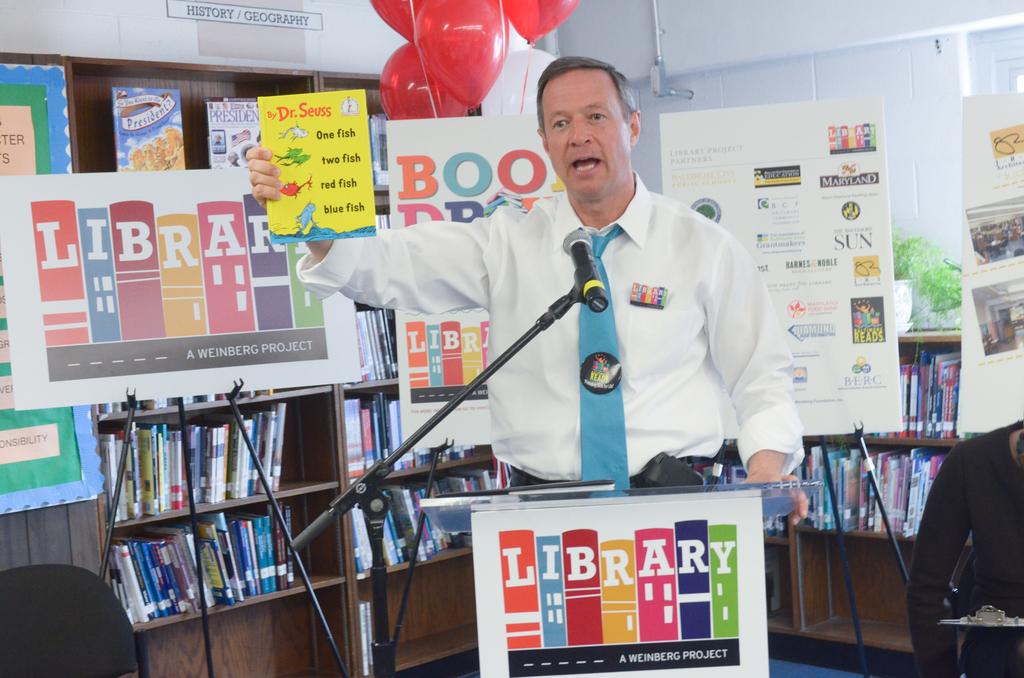What word is seen before the man?
Your response must be concise. Library. 